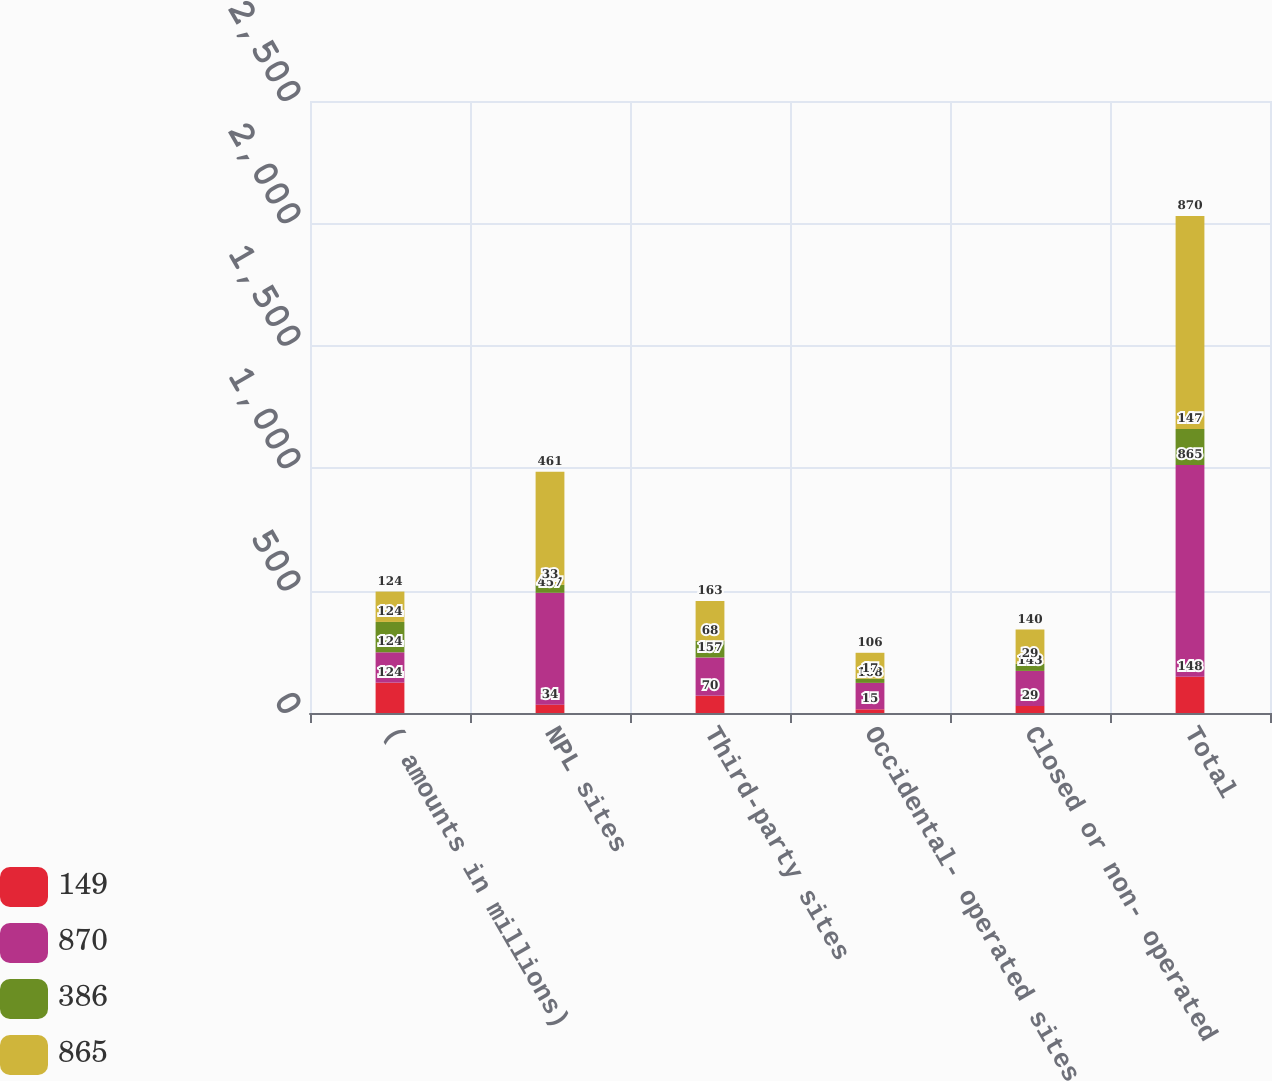<chart> <loc_0><loc_0><loc_500><loc_500><stacked_bar_chart><ecel><fcel>( amounts in millions)<fcel>NPL sites<fcel>Third-party sites<fcel>Occidental- operated sites<fcel>Closed or non- operated<fcel>Total<nl><fcel>149<fcel>124<fcel>34<fcel>70<fcel>15<fcel>29<fcel>148<nl><fcel>870<fcel>124<fcel>457<fcel>157<fcel>108<fcel>143<fcel>865<nl><fcel>386<fcel>124<fcel>33<fcel>68<fcel>17<fcel>29<fcel>147<nl><fcel>865<fcel>124<fcel>461<fcel>163<fcel>106<fcel>140<fcel>870<nl></chart> 